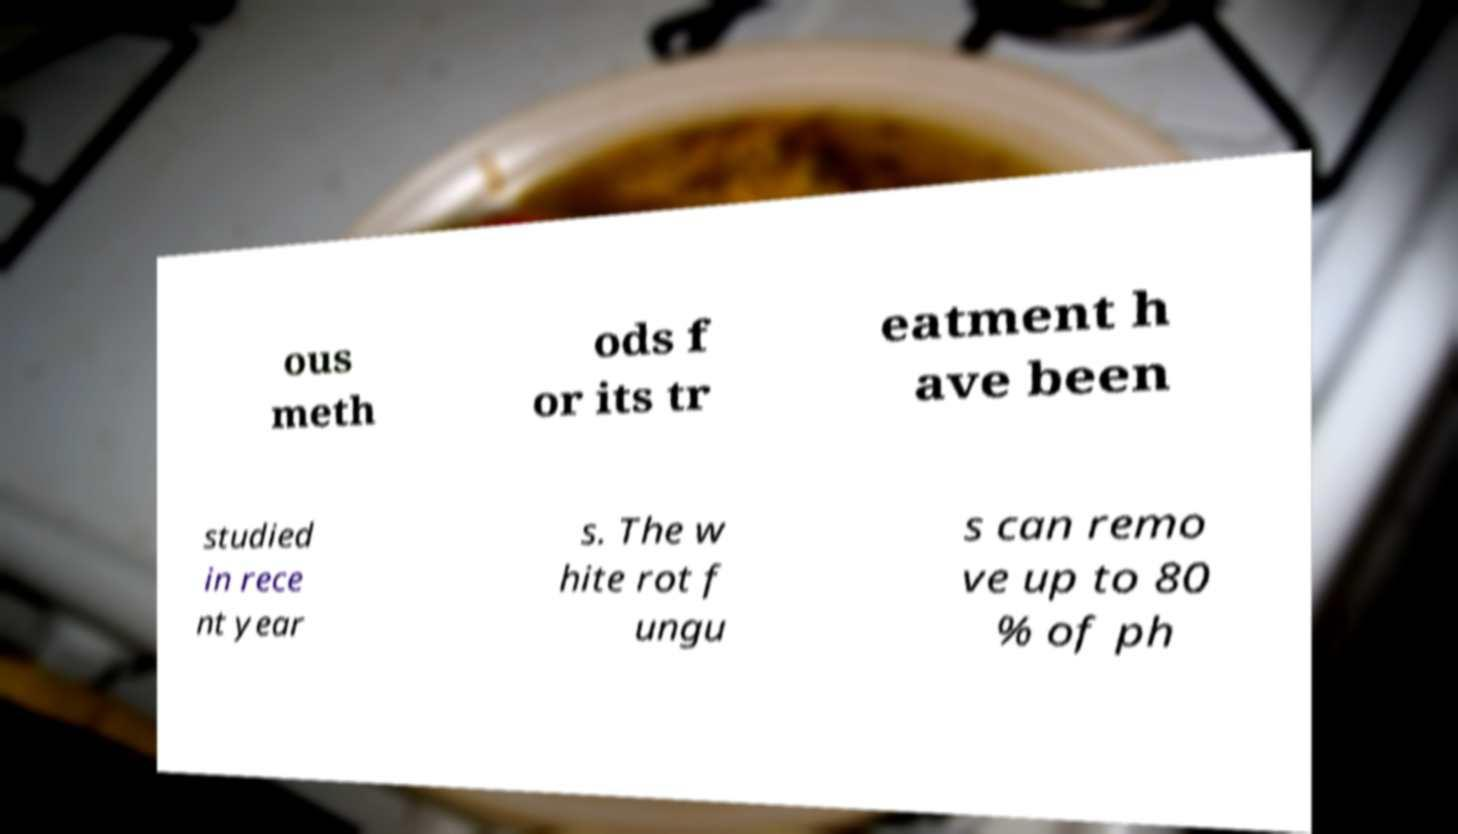There's text embedded in this image that I need extracted. Can you transcribe it verbatim? ous meth ods f or its tr eatment h ave been studied in rece nt year s. The w hite rot f ungu s can remo ve up to 80 % of ph 